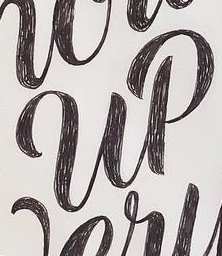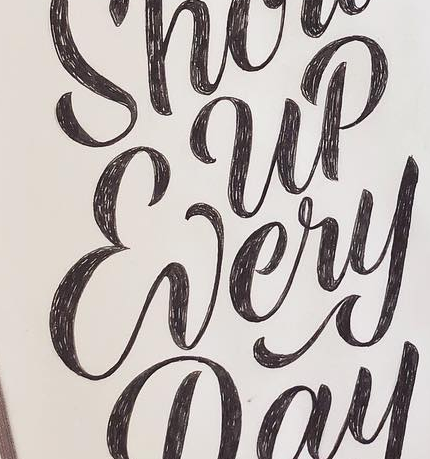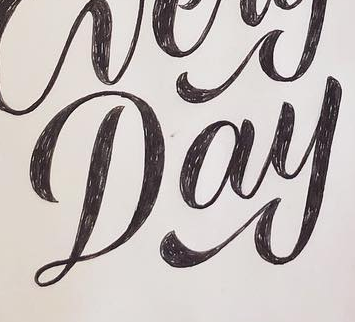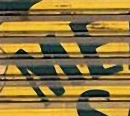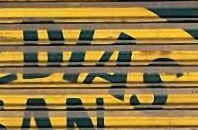What text is displayed in these images sequentially, separated by a semicolon? up; Every; Day; ME; DIAS 